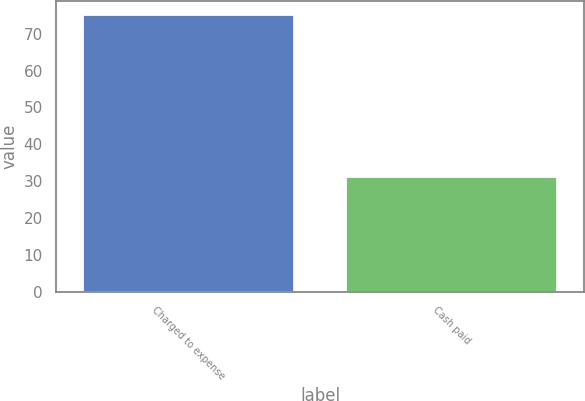Convert chart to OTSL. <chart><loc_0><loc_0><loc_500><loc_500><bar_chart><fcel>Charged to expense<fcel>Cash paid<nl><fcel>75<fcel>31<nl></chart> 